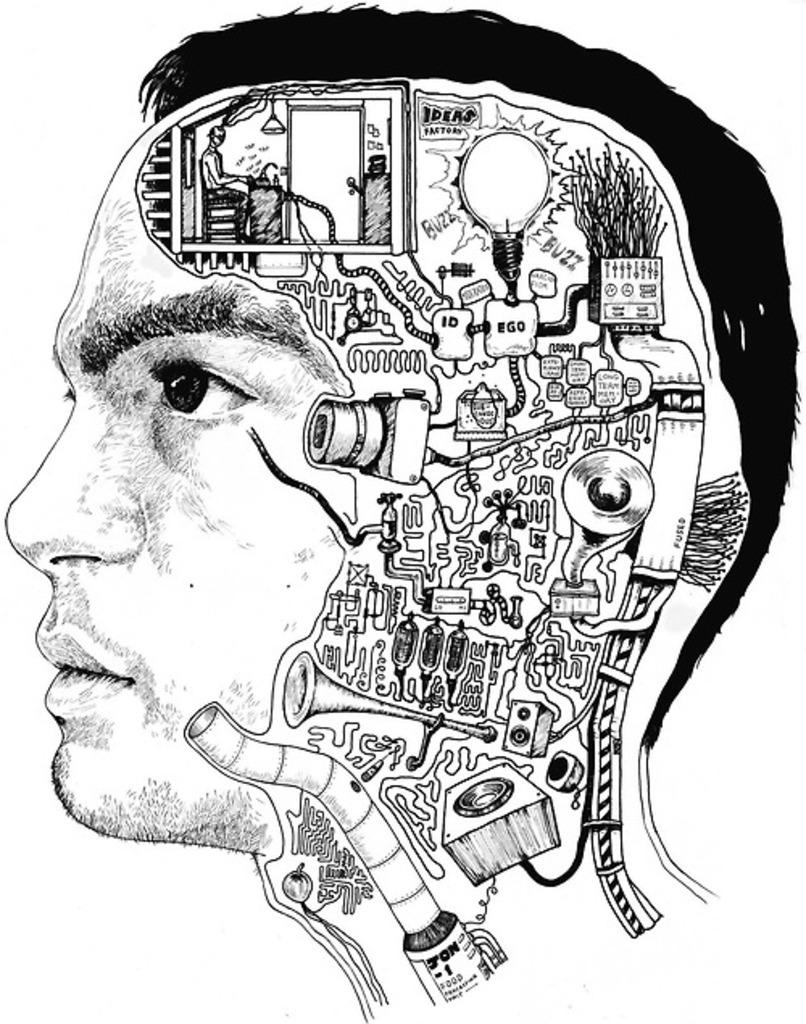How many people can be seen in the image? There are persons in the image, but the exact number is not specified. What are the persons doing in the image? The persons are likely playing instruments, as instruments are visible in the image. What device is used to capture the scene in the image? A camera is visible in the image. What type of lighting is present in the image? There are lights in the image. What is the purpose of the door in the image? The door may provide access to the room or space where the scene is taking place. What are the tables used for in the image? The tables may be used to hold instruments, speakers, or other objects. What type of sound equipment is visible in the image? Speakers are visible in the image. What other objects can be seen in the image besides the ones mentioned? There are other objects in the image, but their specific nature is not described. How does the actor perform their lines in the image? There is no actor or dialogue present in the image; it features persons playing instruments and other objects related to a performance or recording setup. 